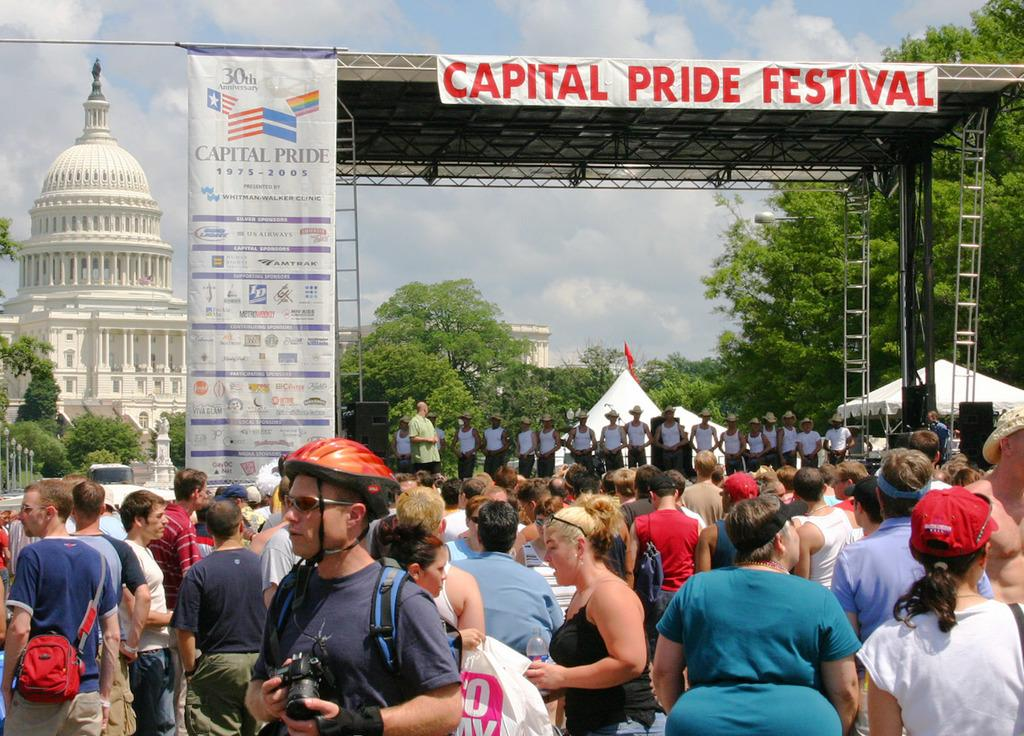What is the main subject of the image? The main subject of the image is a crowd. What can be seen in the image besides the crowd? There are banners, trees, plants, a building, and the sky visible in the image. What type of vegetation is present in the image? There are trees and plants in the image. What is visible in the background of the image? The sky is visible in the background of the image. What does the mother say about love in the image? There is no mention of a mother or love in the image; it features a crowd, banners, trees, plants, a building, and the sky. 